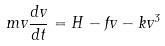<formula> <loc_0><loc_0><loc_500><loc_500>m v \frac { d v } { d t } = H - f v - k v ^ { 3 }</formula> 